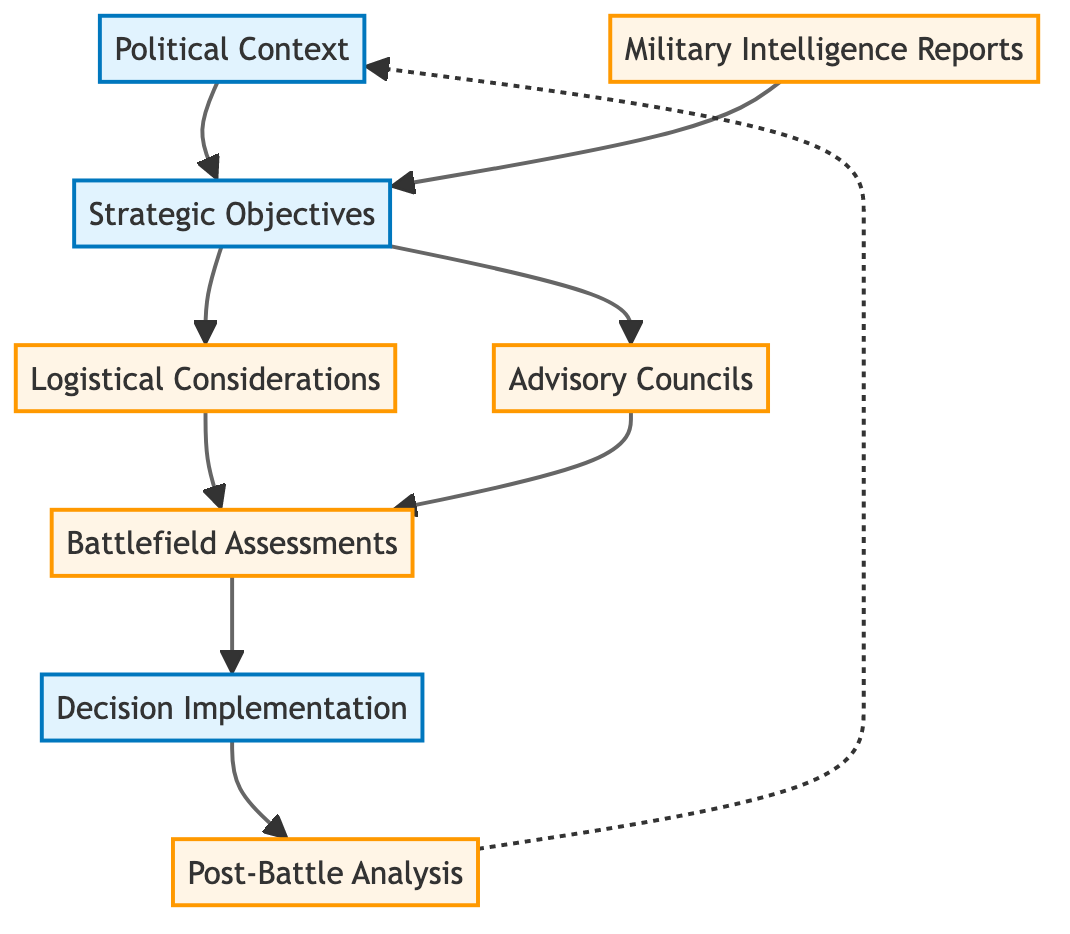What is the first node in the flow chart? The first node in the flow chart is labeled "Political Context," indicating it is the starting point of the decision-making process.
Answer: Political Context How many total nodes are there in the diagram? By counting each distinct box in the flow chart, we find there are a total of eight nodes.
Answer: 8 Which node follows "Military Intelligence Reports"? The node directly connected to "Military Intelligence Reports" is "Strategic Objectives," showing the progression from intelligence to strategic planning.
Answer: Strategic Objectives What connects "Logistical Considerations" to "Battlefield Assessments"? "Logistical Considerations" connects to "Battlefield Assessments" through an arrow, indicating that logistical planning is evaluated alongside assessments of the battlefield.
Answer: Arrow What is the last process in the decision-making flow? The last process in the flow is "Post-Battle Analysis," indicating a retrospective evaluation of the outcomes of the previous decisions.
Answer: Post-Battle Analysis Which two nodes are outcomes of "Strategic Objectives"? The two nodes that stem from "Strategic Objectives" are "Logistical Considerations" and "Advisory Councils," showing that these areas are directly informed by the strategic goals set.
Answer: Logistical Considerations and Advisory Councils How does the flowchart indicate the relationship between "Decision Implementation" and "Post-Battle Analysis"? The relationship is indicated by a directional arrow going from "Decision Implementation" to "Post-Battle Analysis," showing that post-battle evaluations follow the implementation of decisions.
Answer: Arrow What type of assessments does "Battlefield Assessments" include? "Battlefield Assessments" includes evaluations of terrain and weather conditions, critical for making informed military decisions.
Answer: Terrain and weather conditions What is the role of "Advisory Councils" in the decision-making process? "Advisory Councils" involve consultations with military leaders, which aids in formulating better strategies based on expert military opinions.
Answer: Consultations with military leaders 